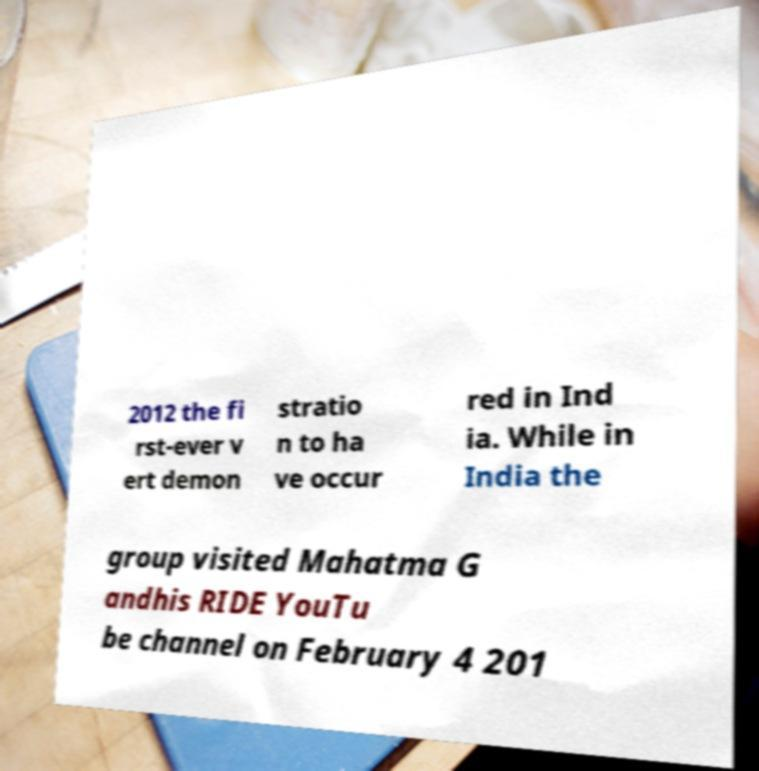There's text embedded in this image that I need extracted. Can you transcribe it verbatim? 2012 the fi rst-ever v ert demon stratio n to ha ve occur red in Ind ia. While in India the group visited Mahatma G andhis RIDE YouTu be channel on February 4 201 